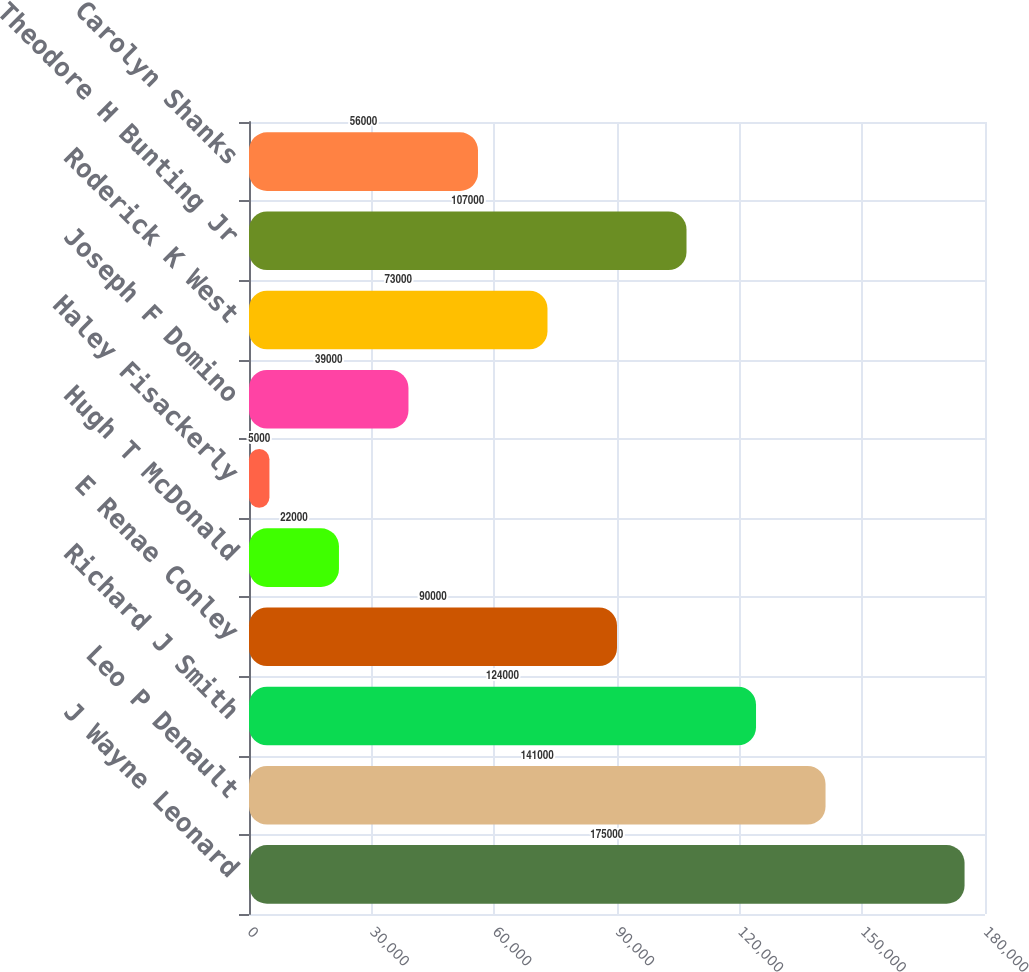<chart> <loc_0><loc_0><loc_500><loc_500><bar_chart><fcel>J Wayne Leonard<fcel>Leo P Denault<fcel>Richard J Smith<fcel>E Renae Conley<fcel>Hugh T McDonald<fcel>Haley Fisackerly<fcel>Joseph F Domino<fcel>Roderick K West<fcel>Theodore H Bunting Jr<fcel>Carolyn Shanks<nl><fcel>175000<fcel>141000<fcel>124000<fcel>90000<fcel>22000<fcel>5000<fcel>39000<fcel>73000<fcel>107000<fcel>56000<nl></chart> 